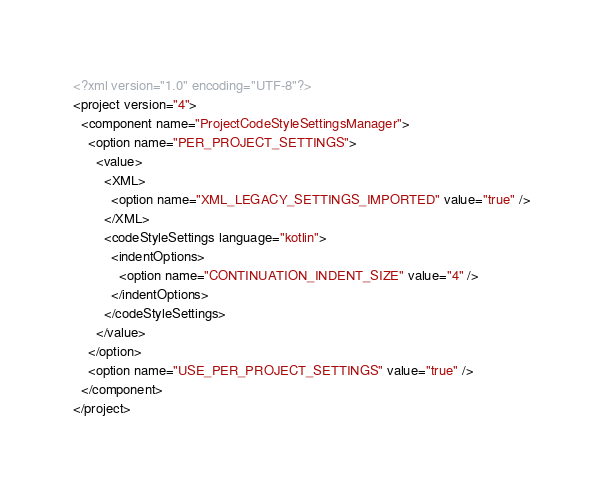<code> <loc_0><loc_0><loc_500><loc_500><_XML_><?xml version="1.0" encoding="UTF-8"?>
<project version="4">
  <component name="ProjectCodeStyleSettingsManager">
    <option name="PER_PROJECT_SETTINGS">
      <value>
        <XML>
          <option name="XML_LEGACY_SETTINGS_IMPORTED" value="true" />
        </XML>
        <codeStyleSettings language="kotlin">
          <indentOptions>
            <option name="CONTINUATION_INDENT_SIZE" value="4" />
          </indentOptions>
        </codeStyleSettings>
      </value>
    </option>
    <option name="USE_PER_PROJECT_SETTINGS" value="true" />
  </component>
</project></code> 